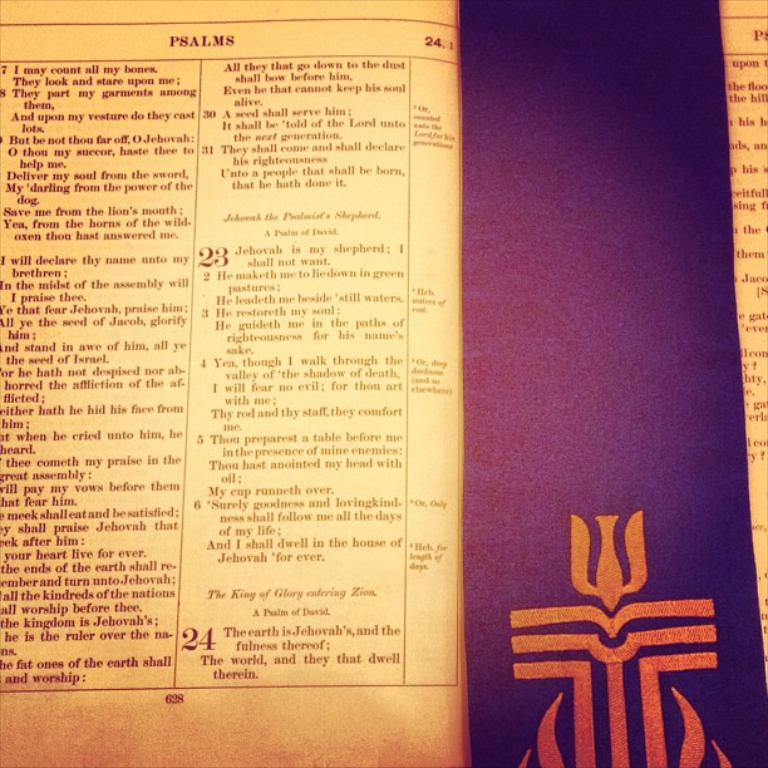Provide a one-sentence caption for the provided image. a page in a book with a religious touch, the top of the page reads PSALMS which describes what the page says below it. 